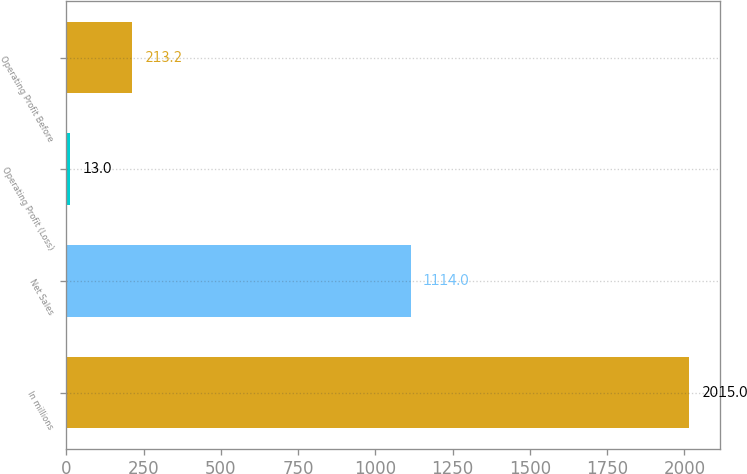<chart> <loc_0><loc_0><loc_500><loc_500><bar_chart><fcel>In millions<fcel>Net Sales<fcel>Operating Profit (Loss)<fcel>Operating Profit Before<nl><fcel>2015<fcel>1114<fcel>13<fcel>213.2<nl></chart> 